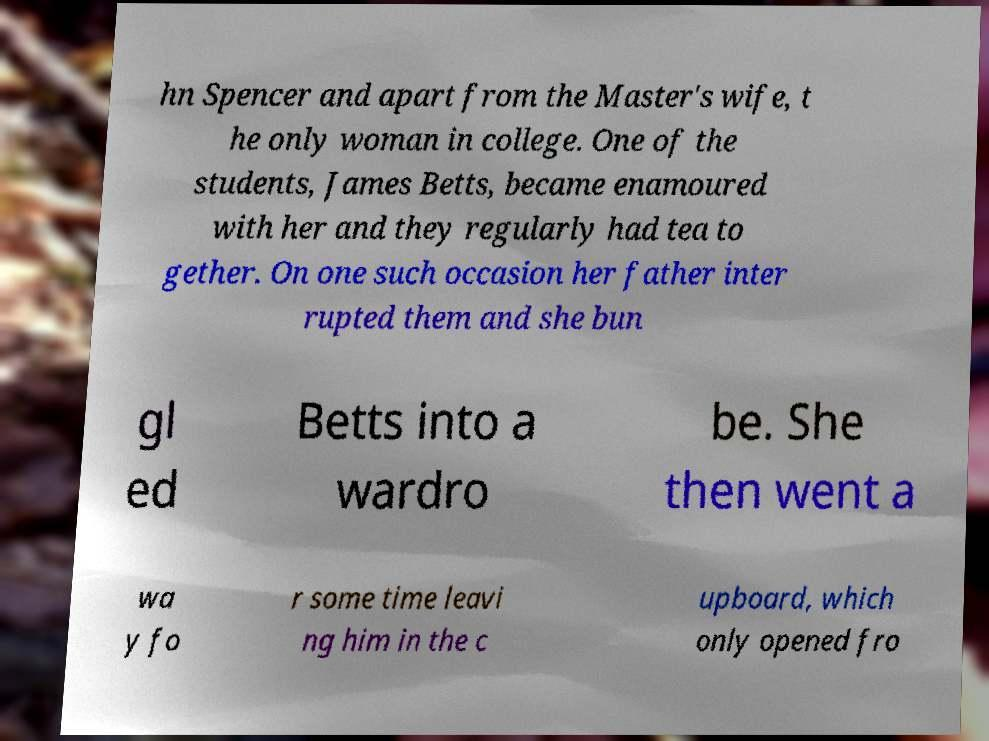There's text embedded in this image that I need extracted. Can you transcribe it verbatim? hn Spencer and apart from the Master's wife, t he only woman in college. One of the students, James Betts, became enamoured with her and they regularly had tea to gether. On one such occasion her father inter rupted them and she bun gl ed Betts into a wardro be. She then went a wa y fo r some time leavi ng him in the c upboard, which only opened fro 